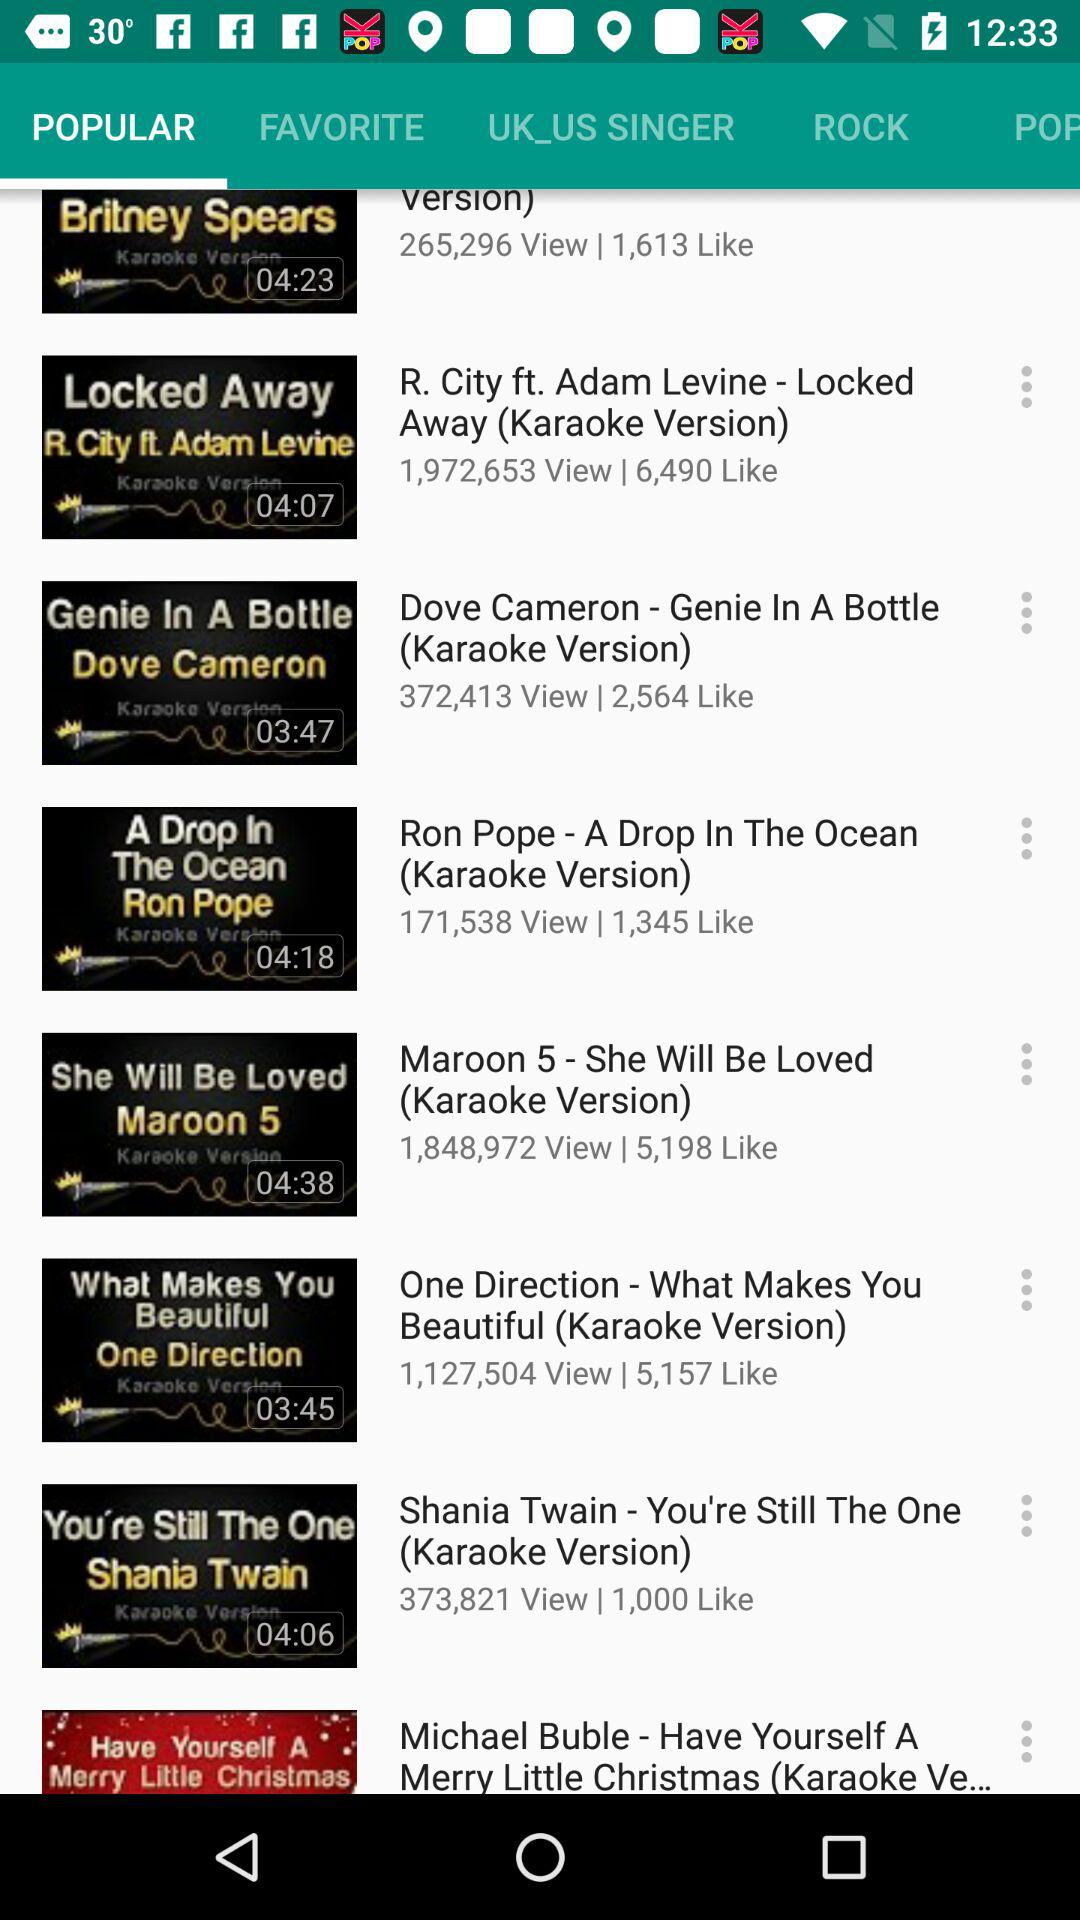What is the duration of Shania Twain? The duration of Shania Twain is 04:06. 